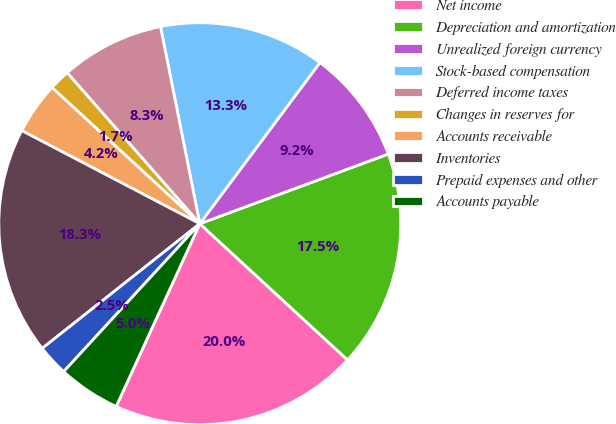Convert chart to OTSL. <chart><loc_0><loc_0><loc_500><loc_500><pie_chart><fcel>Net income<fcel>Depreciation and amortization<fcel>Unrealized foreign currency<fcel>Stock-based compensation<fcel>Deferred income taxes<fcel>Changes in reserves for<fcel>Accounts receivable<fcel>Inventories<fcel>Prepaid expenses and other<fcel>Accounts payable<nl><fcel>19.98%<fcel>17.49%<fcel>9.17%<fcel>13.33%<fcel>8.34%<fcel>1.68%<fcel>4.18%<fcel>18.32%<fcel>2.51%<fcel>5.01%<nl></chart> 